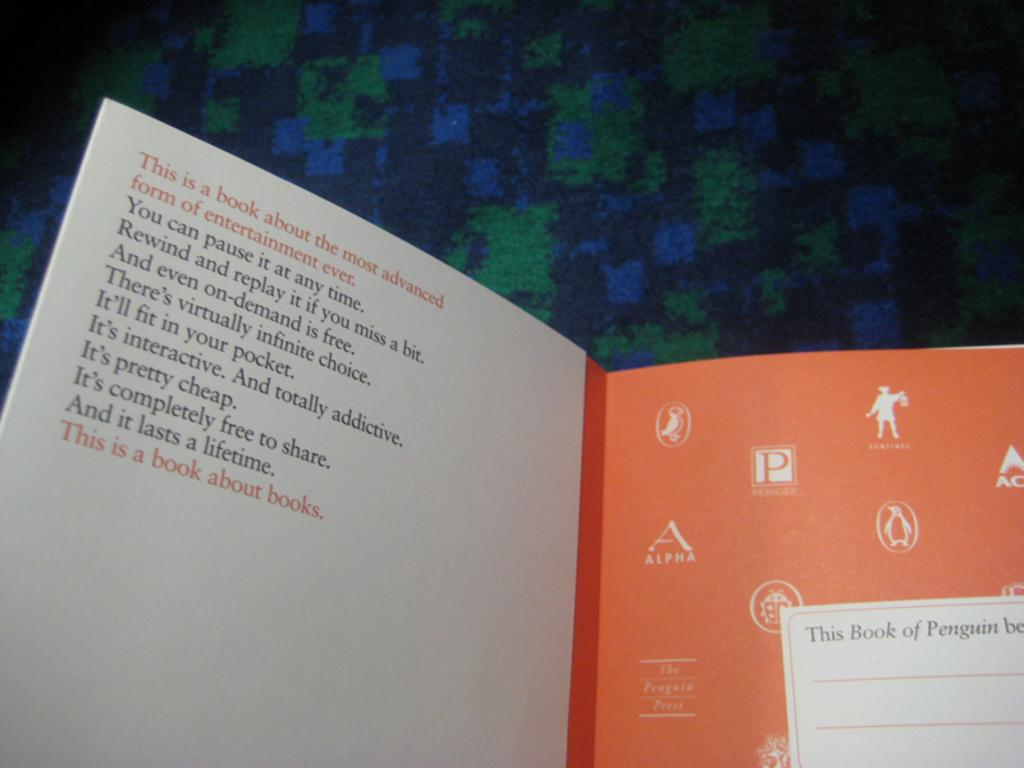<image>
Summarize the visual content of the image. An open book with the words This is a book about the most Advanced form of Entertainment Ever on the top. 